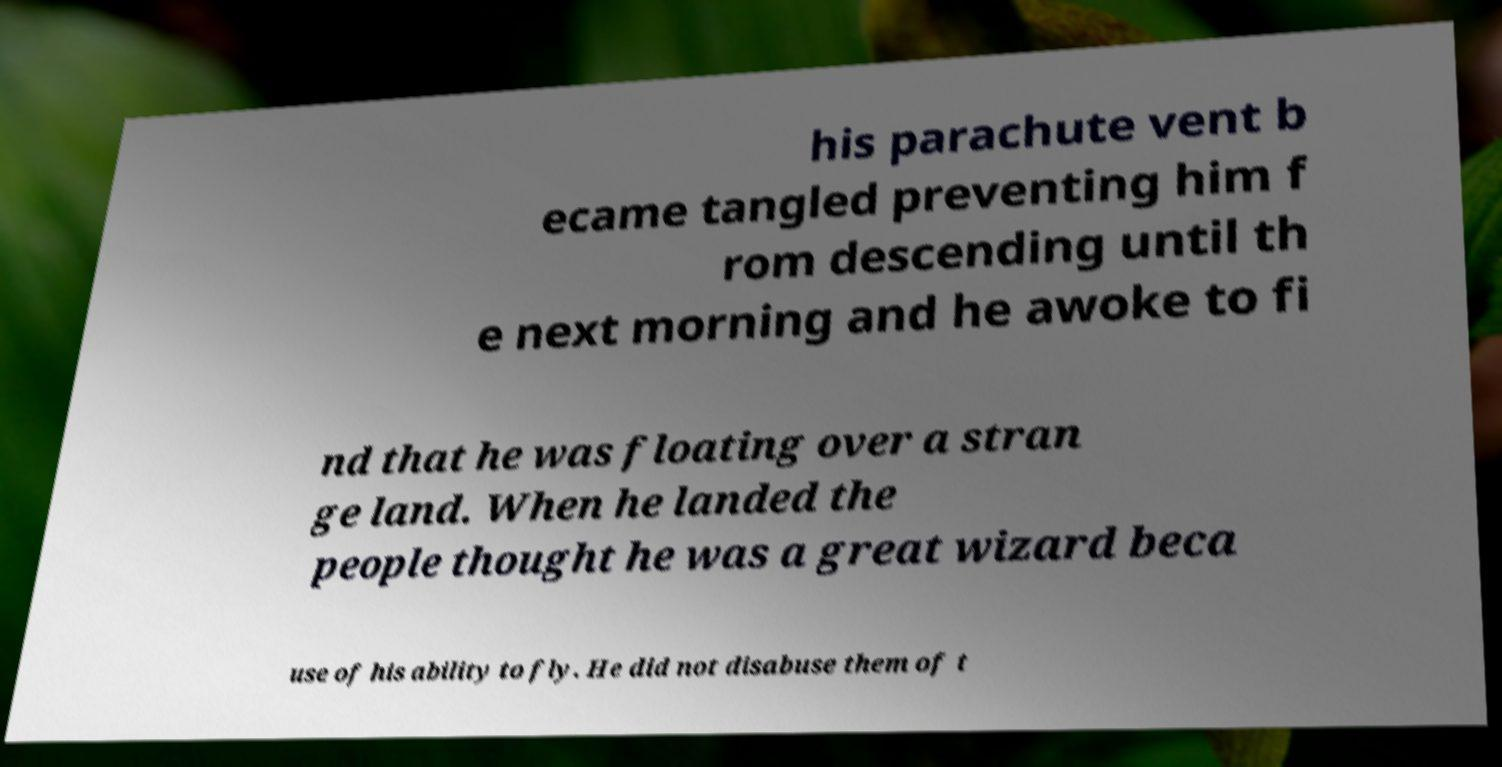For documentation purposes, I need the text within this image transcribed. Could you provide that? his parachute vent b ecame tangled preventing him f rom descending until th e next morning and he awoke to fi nd that he was floating over a stran ge land. When he landed the people thought he was a great wizard beca use of his ability to fly. He did not disabuse them of t 